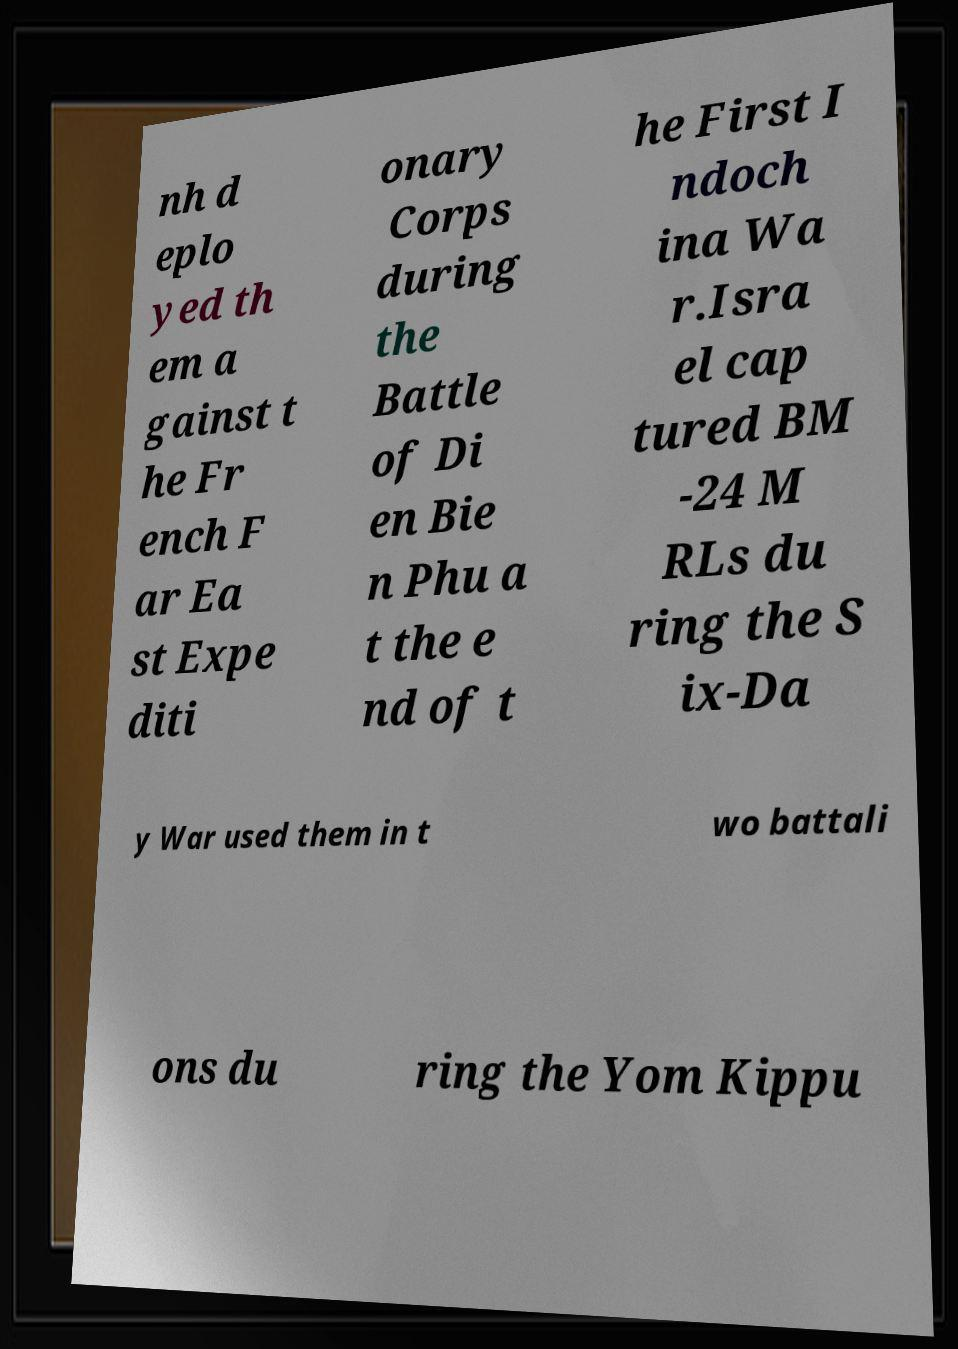Could you extract and type out the text from this image? nh d eplo yed th em a gainst t he Fr ench F ar Ea st Expe diti onary Corps during the Battle of Di en Bie n Phu a t the e nd of t he First I ndoch ina Wa r.Isra el cap tured BM -24 M RLs du ring the S ix-Da y War used them in t wo battali ons du ring the Yom Kippu 